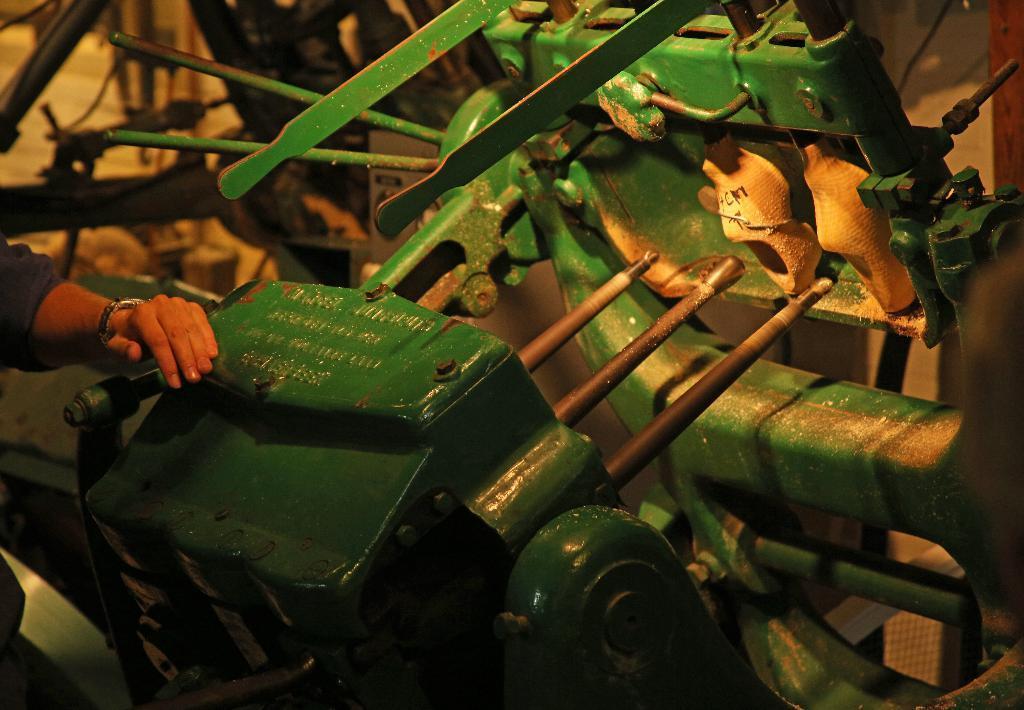Can you describe this image briefly? This image is taken indoors. In the background there is a wall. In the middle of the image there is a machine which is made of iron. There is a text on the machine. On the left side of the image there is a man and he is holding a machine with his hand. 